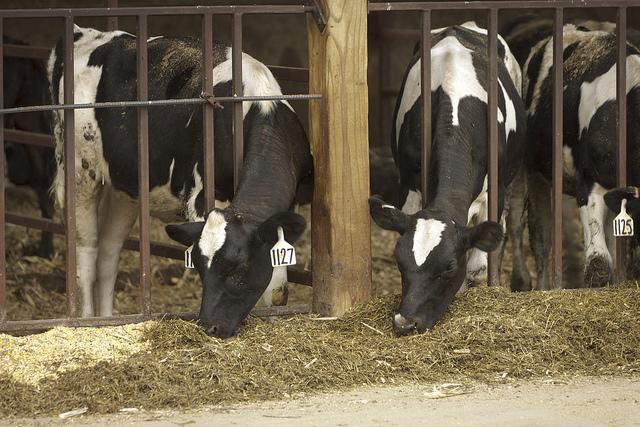Are these cows for milk production? Yes, these cows appear to be dairy cows, which are kept for milk production. 